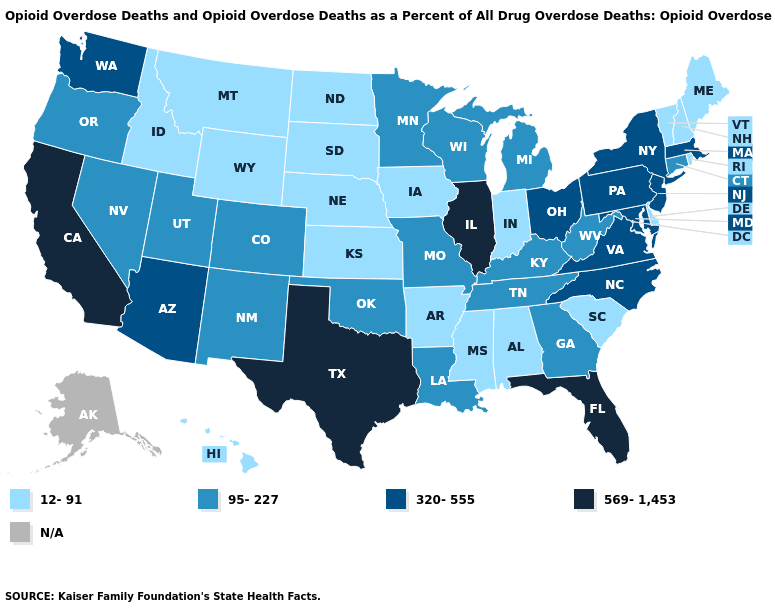Does the map have missing data?
Give a very brief answer. Yes. Name the states that have a value in the range 95-227?
Quick response, please. Colorado, Connecticut, Georgia, Kentucky, Louisiana, Michigan, Minnesota, Missouri, Nevada, New Mexico, Oklahoma, Oregon, Tennessee, Utah, West Virginia, Wisconsin. Name the states that have a value in the range 569-1,453?
Keep it brief. California, Florida, Illinois, Texas. Name the states that have a value in the range 95-227?
Short answer required. Colorado, Connecticut, Georgia, Kentucky, Louisiana, Michigan, Minnesota, Missouri, Nevada, New Mexico, Oklahoma, Oregon, Tennessee, Utah, West Virginia, Wisconsin. What is the lowest value in the USA?
Answer briefly. 12-91. Name the states that have a value in the range 569-1,453?
Quick response, please. California, Florida, Illinois, Texas. What is the highest value in the USA?
Quick response, please. 569-1,453. Which states have the highest value in the USA?
Short answer required. California, Florida, Illinois, Texas. Which states hav the highest value in the Northeast?
Short answer required. Massachusetts, New Jersey, New York, Pennsylvania. Which states have the highest value in the USA?
Be succinct. California, Florida, Illinois, Texas. Does Pennsylvania have the lowest value in the USA?
Write a very short answer. No. What is the lowest value in the Northeast?
Quick response, please. 12-91. Among the states that border Arkansas , which have the highest value?
Keep it brief. Texas. Among the states that border Massachusetts , does Rhode Island have the lowest value?
Quick response, please. Yes. 